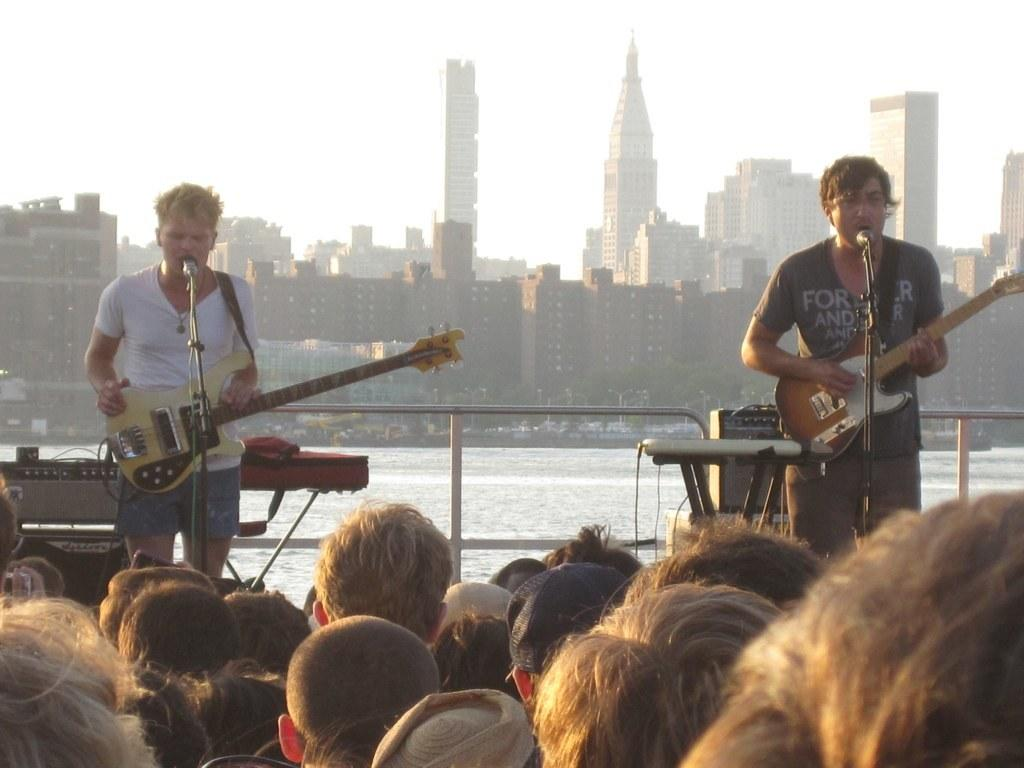How many men are in the image? There are two men in the image. What are the men doing in the image? The men are holding and playing guitars, and they are singing. What object is present for amplifying their voices? There is a microphone in the image. Who else is present in the image besides the two men? There is a group of people in the image. Can you describe any objects in the image that might be used for carrying items? There is a bag in the image. What can be seen in the background of the image? Water and a building are visible in the background of the image. What type of bread is being sold by the beggar in the image? There is no beggar or bread present in the image. What crime is being committed by the men in the image? There is no crime being committed by the men in the image; they are playing guitars and singing. 